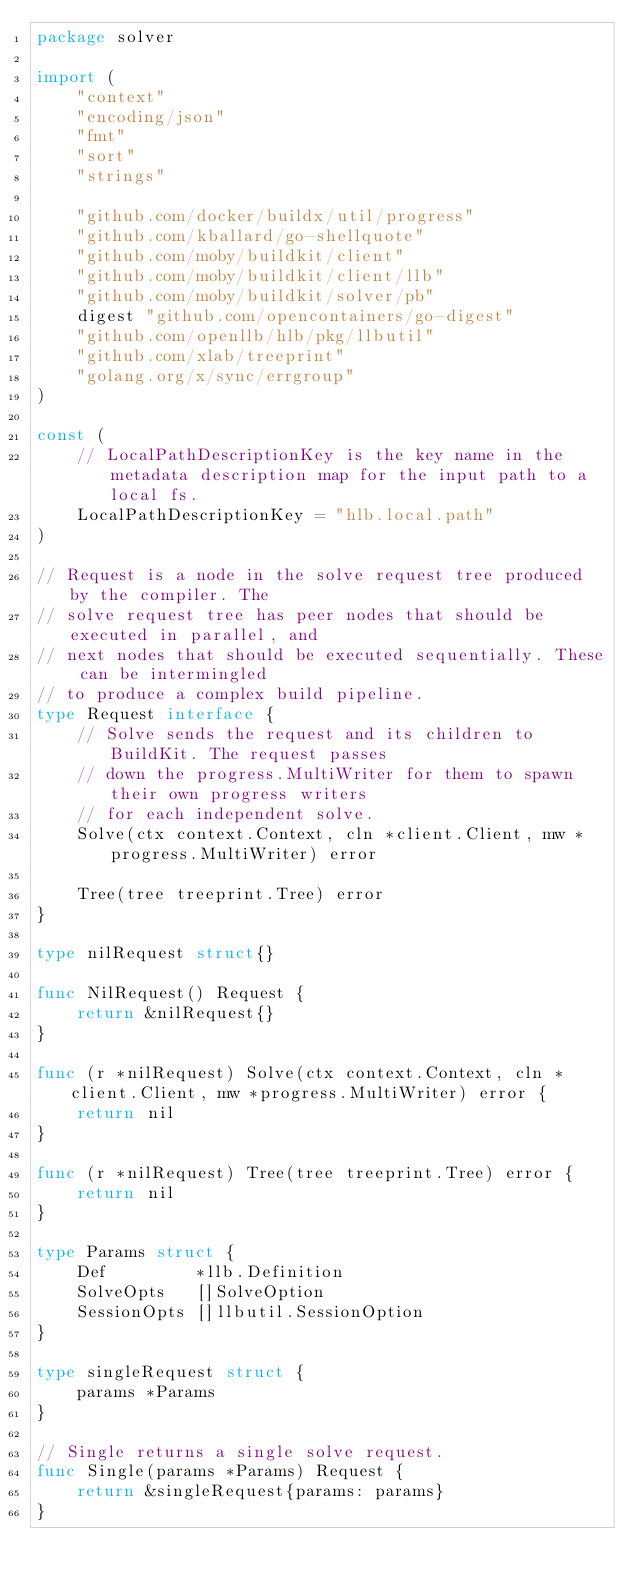<code> <loc_0><loc_0><loc_500><loc_500><_Go_>package solver

import (
	"context"
	"encoding/json"
	"fmt"
	"sort"
	"strings"

	"github.com/docker/buildx/util/progress"
	"github.com/kballard/go-shellquote"
	"github.com/moby/buildkit/client"
	"github.com/moby/buildkit/client/llb"
	"github.com/moby/buildkit/solver/pb"
	digest "github.com/opencontainers/go-digest"
	"github.com/openllb/hlb/pkg/llbutil"
	"github.com/xlab/treeprint"
	"golang.org/x/sync/errgroup"
)

const (
	// LocalPathDescriptionKey is the key name in the metadata description map for the input path to a local fs.
	LocalPathDescriptionKey = "hlb.local.path"
)

// Request is a node in the solve request tree produced by the compiler. The
// solve request tree has peer nodes that should be executed in parallel, and
// next nodes that should be executed sequentially. These can be intermingled
// to produce a complex build pipeline.
type Request interface {
	// Solve sends the request and its children to BuildKit. The request passes
	// down the progress.MultiWriter for them to spawn their own progress writers
	// for each independent solve.
	Solve(ctx context.Context, cln *client.Client, mw *progress.MultiWriter) error

	Tree(tree treeprint.Tree) error
}

type nilRequest struct{}

func NilRequest() Request {
	return &nilRequest{}
}

func (r *nilRequest) Solve(ctx context.Context, cln *client.Client, mw *progress.MultiWriter) error {
	return nil
}

func (r *nilRequest) Tree(tree treeprint.Tree) error {
	return nil
}

type Params struct {
	Def         *llb.Definition
	SolveOpts   []SolveOption
	SessionOpts []llbutil.SessionOption
}

type singleRequest struct {
	params *Params
}

// Single returns a single solve request.
func Single(params *Params) Request {
	return &singleRequest{params: params}
}
</code> 